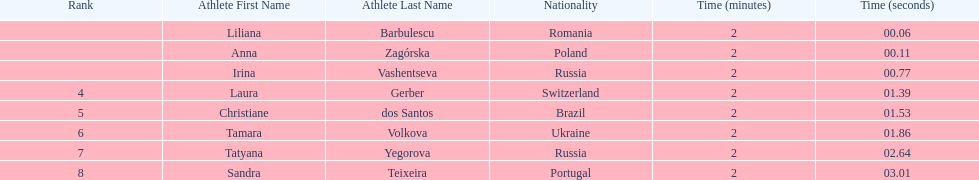What is the number of russian participants in this set of semifinals? 2. 